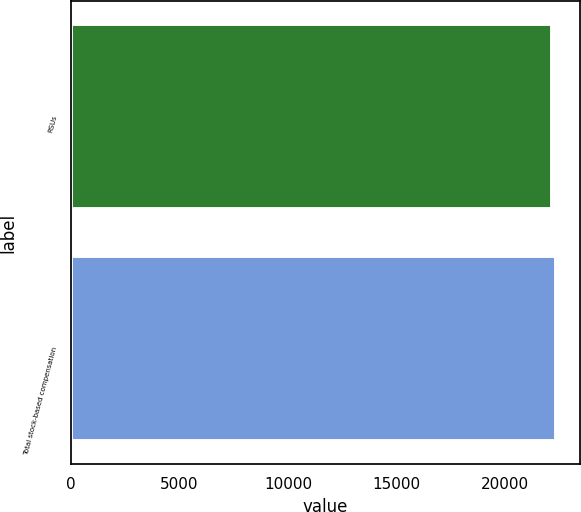<chart> <loc_0><loc_0><loc_500><loc_500><bar_chart><fcel>RSUs<fcel>Total stock-based compensation<nl><fcel>22183<fcel>22345<nl></chart> 